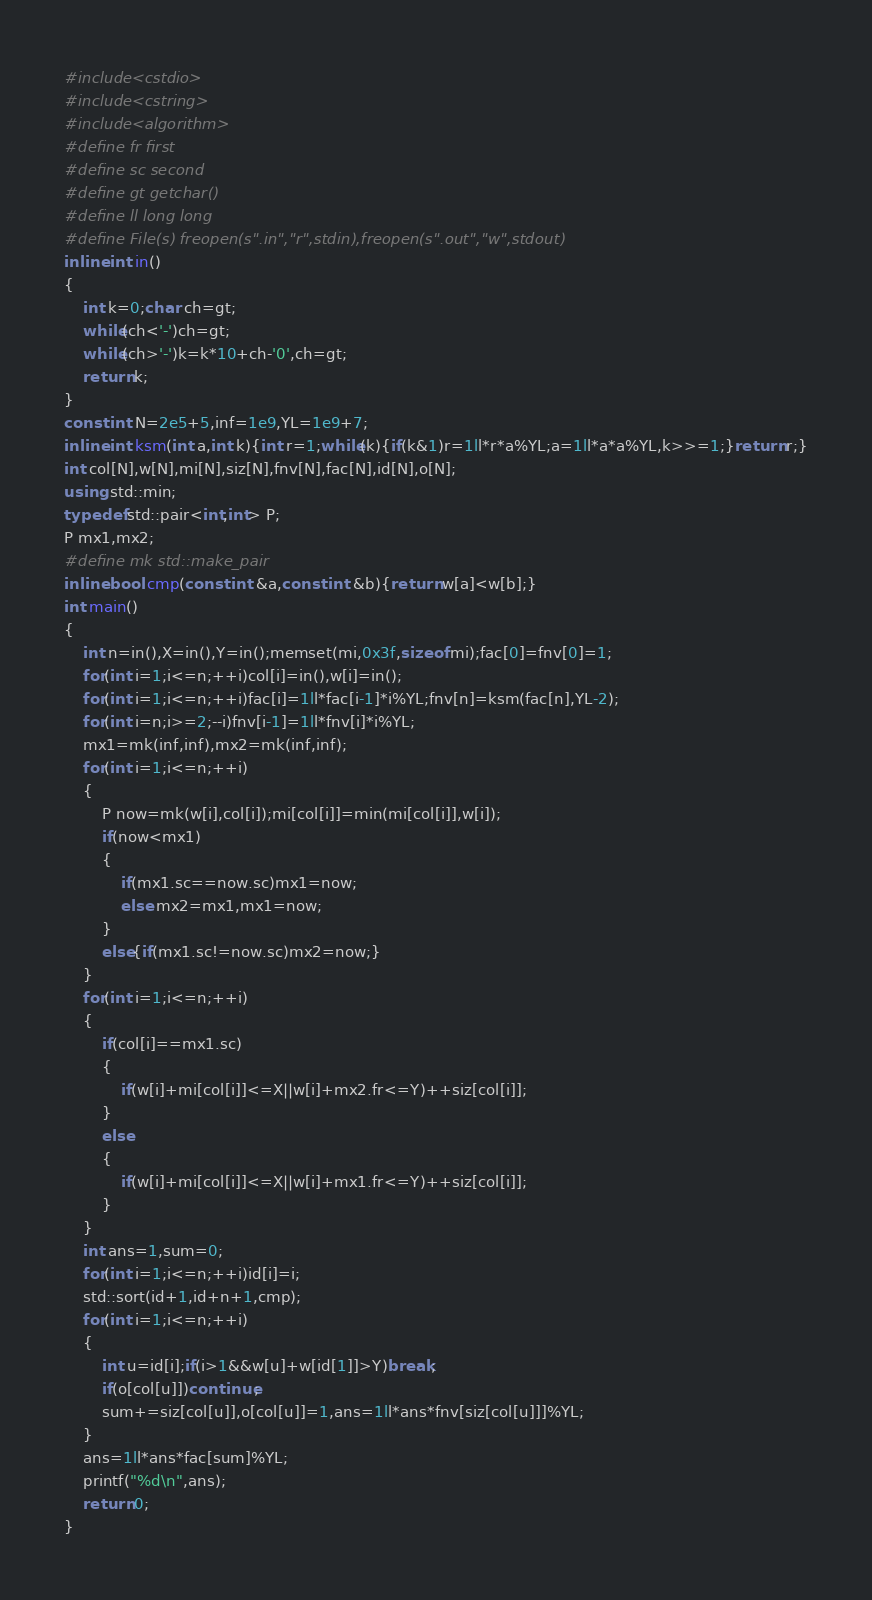Convert code to text. <code><loc_0><loc_0><loc_500><loc_500><_C++_>#include<cstdio>
#include<cstring>
#include<algorithm>
#define fr first
#define sc second
#define gt getchar()
#define ll long long
#define File(s) freopen(s".in","r",stdin),freopen(s".out","w",stdout)
inline int in()
{
	int k=0;char ch=gt;
	while(ch<'-')ch=gt;
	while(ch>'-')k=k*10+ch-'0',ch=gt;
	return k;
}
const int N=2e5+5,inf=1e9,YL=1e9+7;
inline int ksm(int a,int k){int r=1;while(k){if(k&1)r=1ll*r*a%YL;a=1ll*a*a%YL,k>>=1;}return r;}
int col[N],w[N],mi[N],siz[N],fnv[N],fac[N],id[N],o[N];
using std::min;
typedef std::pair<int,int> P;
P mx1,mx2;
#define mk std::make_pair
inline bool cmp(const int &a,const int &b){return w[a]<w[b];}
int main()
{
	int n=in(),X=in(),Y=in();memset(mi,0x3f,sizeof mi);fac[0]=fnv[0]=1;
	for(int i=1;i<=n;++i)col[i]=in(),w[i]=in();
	for(int i=1;i<=n;++i)fac[i]=1ll*fac[i-1]*i%YL;fnv[n]=ksm(fac[n],YL-2);
	for(int i=n;i>=2;--i)fnv[i-1]=1ll*fnv[i]*i%YL;
	mx1=mk(inf,inf),mx2=mk(inf,inf);
	for(int i=1;i<=n;++i)
	{
		P now=mk(w[i],col[i]);mi[col[i]]=min(mi[col[i]],w[i]);
		if(now<mx1)
		{
			if(mx1.sc==now.sc)mx1=now;
			else mx2=mx1,mx1=now;
		}
		else{if(mx1.sc!=now.sc)mx2=now;}
	}
	for(int i=1;i<=n;++i)
	{
		if(col[i]==mx1.sc)
		{
			if(w[i]+mi[col[i]]<=X||w[i]+mx2.fr<=Y)++siz[col[i]];
		}
		else
		{
			if(w[i]+mi[col[i]]<=X||w[i]+mx1.fr<=Y)++siz[col[i]];
		}
	}
	int ans=1,sum=0;
	for(int i=1;i<=n;++i)id[i]=i;
	std::sort(id+1,id+n+1,cmp);
	for(int i=1;i<=n;++i)
	{
		int u=id[i];if(i>1&&w[u]+w[id[1]]>Y)break;
		if(o[col[u]])continue;
		sum+=siz[col[u]],o[col[u]]=1,ans=1ll*ans*fnv[siz[col[u]]]%YL;
	}
	ans=1ll*ans*fac[sum]%YL;
	printf("%d\n",ans);
	return 0;
}
</code> 